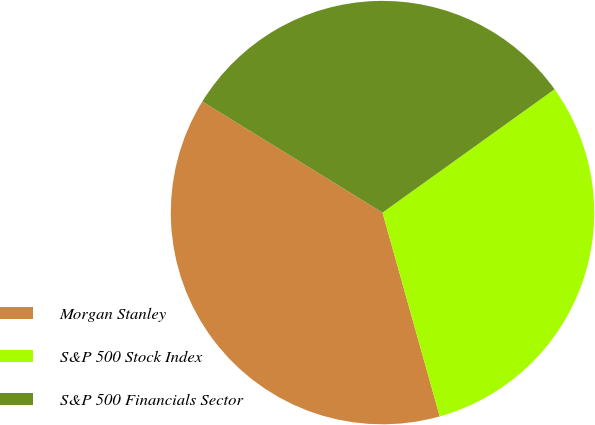<chart> <loc_0><loc_0><loc_500><loc_500><pie_chart><fcel>Morgan Stanley<fcel>S&P 500 Stock Index<fcel>S&P 500 Financials Sector<nl><fcel>38.15%<fcel>30.54%<fcel>31.31%<nl></chart> 